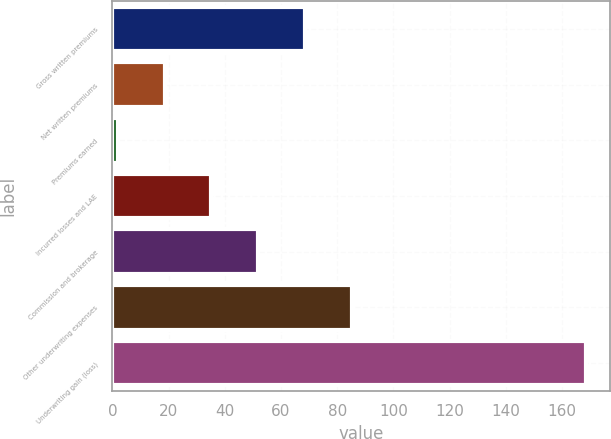Convert chart to OTSL. <chart><loc_0><loc_0><loc_500><loc_500><bar_chart><fcel>Gross written premiums<fcel>Net written premiums<fcel>Premiums earned<fcel>Incurred losses and LAE<fcel>Commission and brokerage<fcel>Other underwriting expenses<fcel>Underwriting gain (loss)<nl><fcel>68.58<fcel>18.57<fcel>1.9<fcel>35.24<fcel>51.91<fcel>85.25<fcel>168.6<nl></chart> 